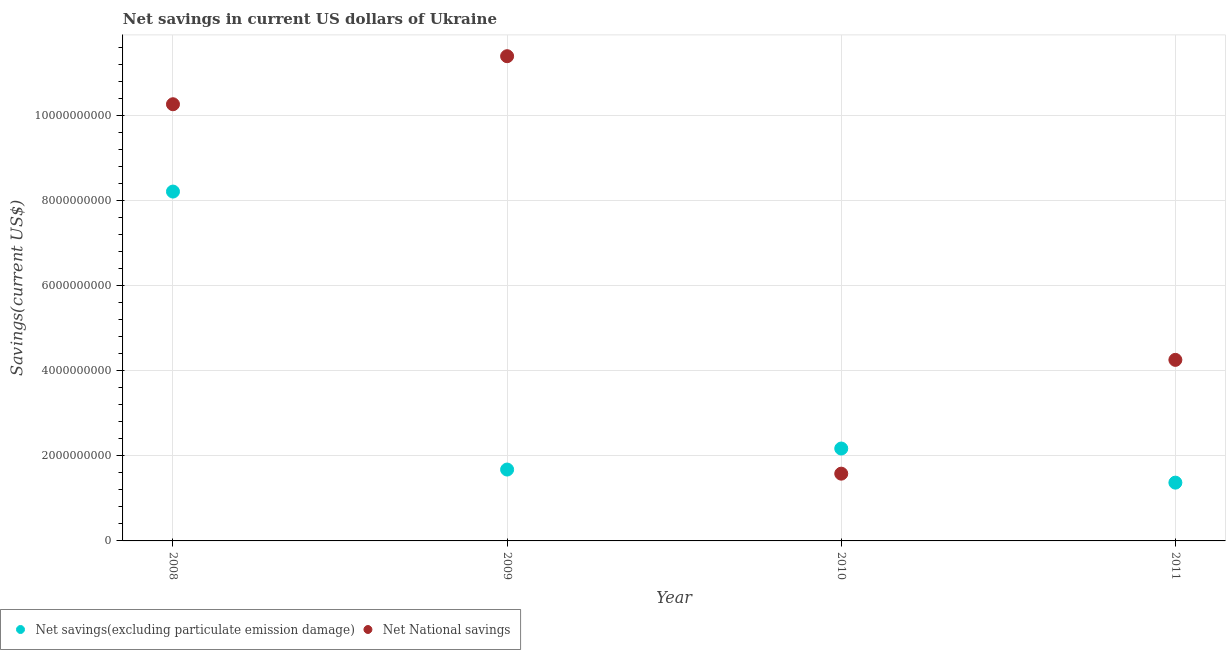How many different coloured dotlines are there?
Ensure brevity in your answer.  2. What is the net savings(excluding particulate emission damage) in 2010?
Make the answer very short. 2.17e+09. Across all years, what is the maximum net savings(excluding particulate emission damage)?
Keep it short and to the point. 8.22e+09. Across all years, what is the minimum net savings(excluding particulate emission damage)?
Your answer should be compact. 1.37e+09. In which year was the net national savings maximum?
Your answer should be very brief. 2009. What is the total net savings(excluding particulate emission damage) in the graph?
Your answer should be compact. 1.34e+1. What is the difference between the net savings(excluding particulate emission damage) in 2008 and that in 2009?
Give a very brief answer. 6.54e+09. What is the difference between the net savings(excluding particulate emission damage) in 2011 and the net national savings in 2010?
Your response must be concise. -2.11e+08. What is the average net national savings per year?
Offer a very short reply. 6.88e+09. In the year 2010, what is the difference between the net savings(excluding particulate emission damage) and net national savings?
Your answer should be very brief. 5.91e+08. In how many years, is the net savings(excluding particulate emission damage) greater than 400000000 US$?
Provide a short and direct response. 4. What is the ratio of the net national savings in 2010 to that in 2011?
Offer a terse response. 0.37. Is the difference between the net national savings in 2010 and 2011 greater than the difference between the net savings(excluding particulate emission damage) in 2010 and 2011?
Provide a succinct answer. No. What is the difference between the highest and the second highest net national savings?
Make the answer very short. 1.13e+09. What is the difference between the highest and the lowest net savings(excluding particulate emission damage)?
Your answer should be very brief. 6.85e+09. Is the sum of the net national savings in 2008 and 2011 greater than the maximum net savings(excluding particulate emission damage) across all years?
Make the answer very short. Yes. Is the net national savings strictly greater than the net savings(excluding particulate emission damage) over the years?
Your answer should be compact. No. Is the net savings(excluding particulate emission damage) strictly less than the net national savings over the years?
Your response must be concise. No. How many dotlines are there?
Give a very brief answer. 2. What is the difference between two consecutive major ticks on the Y-axis?
Offer a very short reply. 2.00e+09. Are the values on the major ticks of Y-axis written in scientific E-notation?
Offer a very short reply. No. Does the graph contain grids?
Your answer should be very brief. Yes. Where does the legend appear in the graph?
Keep it short and to the point. Bottom left. How many legend labels are there?
Make the answer very short. 2. What is the title of the graph?
Ensure brevity in your answer.  Net savings in current US dollars of Ukraine. What is the label or title of the Y-axis?
Provide a succinct answer. Savings(current US$). What is the Savings(current US$) of Net savings(excluding particulate emission damage) in 2008?
Give a very brief answer. 8.22e+09. What is the Savings(current US$) of Net National savings in 2008?
Offer a very short reply. 1.03e+1. What is the Savings(current US$) of Net savings(excluding particulate emission damage) in 2009?
Provide a short and direct response. 1.68e+09. What is the Savings(current US$) of Net National savings in 2009?
Offer a very short reply. 1.14e+1. What is the Savings(current US$) in Net savings(excluding particulate emission damage) in 2010?
Your answer should be very brief. 2.17e+09. What is the Savings(current US$) in Net National savings in 2010?
Your answer should be very brief. 1.58e+09. What is the Savings(current US$) in Net savings(excluding particulate emission damage) in 2011?
Your response must be concise. 1.37e+09. What is the Savings(current US$) of Net National savings in 2011?
Give a very brief answer. 4.26e+09. Across all years, what is the maximum Savings(current US$) in Net savings(excluding particulate emission damage)?
Your response must be concise. 8.22e+09. Across all years, what is the maximum Savings(current US$) in Net National savings?
Your response must be concise. 1.14e+1. Across all years, what is the minimum Savings(current US$) of Net savings(excluding particulate emission damage)?
Provide a succinct answer. 1.37e+09. Across all years, what is the minimum Savings(current US$) in Net National savings?
Your answer should be very brief. 1.58e+09. What is the total Savings(current US$) in Net savings(excluding particulate emission damage) in the graph?
Ensure brevity in your answer.  1.34e+1. What is the total Savings(current US$) of Net National savings in the graph?
Your answer should be compact. 2.75e+1. What is the difference between the Savings(current US$) in Net savings(excluding particulate emission damage) in 2008 and that in 2009?
Provide a succinct answer. 6.54e+09. What is the difference between the Savings(current US$) in Net National savings in 2008 and that in 2009?
Your answer should be very brief. -1.13e+09. What is the difference between the Savings(current US$) of Net savings(excluding particulate emission damage) in 2008 and that in 2010?
Ensure brevity in your answer.  6.05e+09. What is the difference between the Savings(current US$) of Net National savings in 2008 and that in 2010?
Give a very brief answer. 8.69e+09. What is the difference between the Savings(current US$) in Net savings(excluding particulate emission damage) in 2008 and that in 2011?
Ensure brevity in your answer.  6.85e+09. What is the difference between the Savings(current US$) of Net National savings in 2008 and that in 2011?
Offer a terse response. 6.01e+09. What is the difference between the Savings(current US$) in Net savings(excluding particulate emission damage) in 2009 and that in 2010?
Ensure brevity in your answer.  -4.95e+08. What is the difference between the Savings(current US$) of Net National savings in 2009 and that in 2010?
Your answer should be compact. 9.82e+09. What is the difference between the Savings(current US$) of Net savings(excluding particulate emission damage) in 2009 and that in 2011?
Your answer should be very brief. 3.08e+08. What is the difference between the Savings(current US$) in Net National savings in 2009 and that in 2011?
Your response must be concise. 7.15e+09. What is the difference between the Savings(current US$) of Net savings(excluding particulate emission damage) in 2010 and that in 2011?
Your answer should be very brief. 8.03e+08. What is the difference between the Savings(current US$) in Net National savings in 2010 and that in 2011?
Provide a short and direct response. -2.68e+09. What is the difference between the Savings(current US$) in Net savings(excluding particulate emission damage) in 2008 and the Savings(current US$) in Net National savings in 2009?
Keep it short and to the point. -3.19e+09. What is the difference between the Savings(current US$) in Net savings(excluding particulate emission damage) in 2008 and the Savings(current US$) in Net National savings in 2010?
Offer a terse response. 6.64e+09. What is the difference between the Savings(current US$) in Net savings(excluding particulate emission damage) in 2008 and the Savings(current US$) in Net National savings in 2011?
Provide a short and direct response. 3.96e+09. What is the difference between the Savings(current US$) of Net savings(excluding particulate emission damage) in 2009 and the Savings(current US$) of Net National savings in 2010?
Provide a short and direct response. 9.67e+07. What is the difference between the Savings(current US$) of Net savings(excluding particulate emission damage) in 2009 and the Savings(current US$) of Net National savings in 2011?
Offer a very short reply. -2.58e+09. What is the difference between the Savings(current US$) in Net savings(excluding particulate emission damage) in 2010 and the Savings(current US$) in Net National savings in 2011?
Make the answer very short. -2.09e+09. What is the average Savings(current US$) in Net savings(excluding particulate emission damage) per year?
Give a very brief answer. 3.36e+09. What is the average Savings(current US$) of Net National savings per year?
Offer a terse response. 6.88e+09. In the year 2008, what is the difference between the Savings(current US$) of Net savings(excluding particulate emission damage) and Savings(current US$) of Net National savings?
Keep it short and to the point. -2.05e+09. In the year 2009, what is the difference between the Savings(current US$) in Net savings(excluding particulate emission damage) and Savings(current US$) in Net National savings?
Your answer should be compact. -9.73e+09. In the year 2010, what is the difference between the Savings(current US$) in Net savings(excluding particulate emission damage) and Savings(current US$) in Net National savings?
Ensure brevity in your answer.  5.91e+08. In the year 2011, what is the difference between the Savings(current US$) of Net savings(excluding particulate emission damage) and Savings(current US$) of Net National savings?
Keep it short and to the point. -2.89e+09. What is the ratio of the Savings(current US$) in Net savings(excluding particulate emission damage) in 2008 to that in 2009?
Your response must be concise. 4.89. What is the ratio of the Savings(current US$) in Net National savings in 2008 to that in 2009?
Make the answer very short. 0.9. What is the ratio of the Savings(current US$) of Net savings(excluding particulate emission damage) in 2008 to that in 2010?
Your answer should be very brief. 3.78. What is the ratio of the Savings(current US$) of Net National savings in 2008 to that in 2010?
Provide a short and direct response. 6.49. What is the ratio of the Savings(current US$) of Net savings(excluding particulate emission damage) in 2008 to that in 2011?
Offer a terse response. 5.99. What is the ratio of the Savings(current US$) of Net National savings in 2008 to that in 2011?
Offer a terse response. 2.41. What is the ratio of the Savings(current US$) in Net savings(excluding particulate emission damage) in 2009 to that in 2010?
Ensure brevity in your answer.  0.77. What is the ratio of the Savings(current US$) in Net National savings in 2009 to that in 2010?
Offer a very short reply. 7.21. What is the ratio of the Savings(current US$) in Net savings(excluding particulate emission damage) in 2009 to that in 2011?
Keep it short and to the point. 1.22. What is the ratio of the Savings(current US$) of Net National savings in 2009 to that in 2011?
Keep it short and to the point. 2.68. What is the ratio of the Savings(current US$) in Net savings(excluding particulate emission damage) in 2010 to that in 2011?
Provide a succinct answer. 1.59. What is the ratio of the Savings(current US$) of Net National savings in 2010 to that in 2011?
Offer a very short reply. 0.37. What is the difference between the highest and the second highest Savings(current US$) of Net savings(excluding particulate emission damage)?
Ensure brevity in your answer.  6.05e+09. What is the difference between the highest and the second highest Savings(current US$) in Net National savings?
Offer a terse response. 1.13e+09. What is the difference between the highest and the lowest Savings(current US$) in Net savings(excluding particulate emission damage)?
Your answer should be very brief. 6.85e+09. What is the difference between the highest and the lowest Savings(current US$) in Net National savings?
Your answer should be very brief. 9.82e+09. 